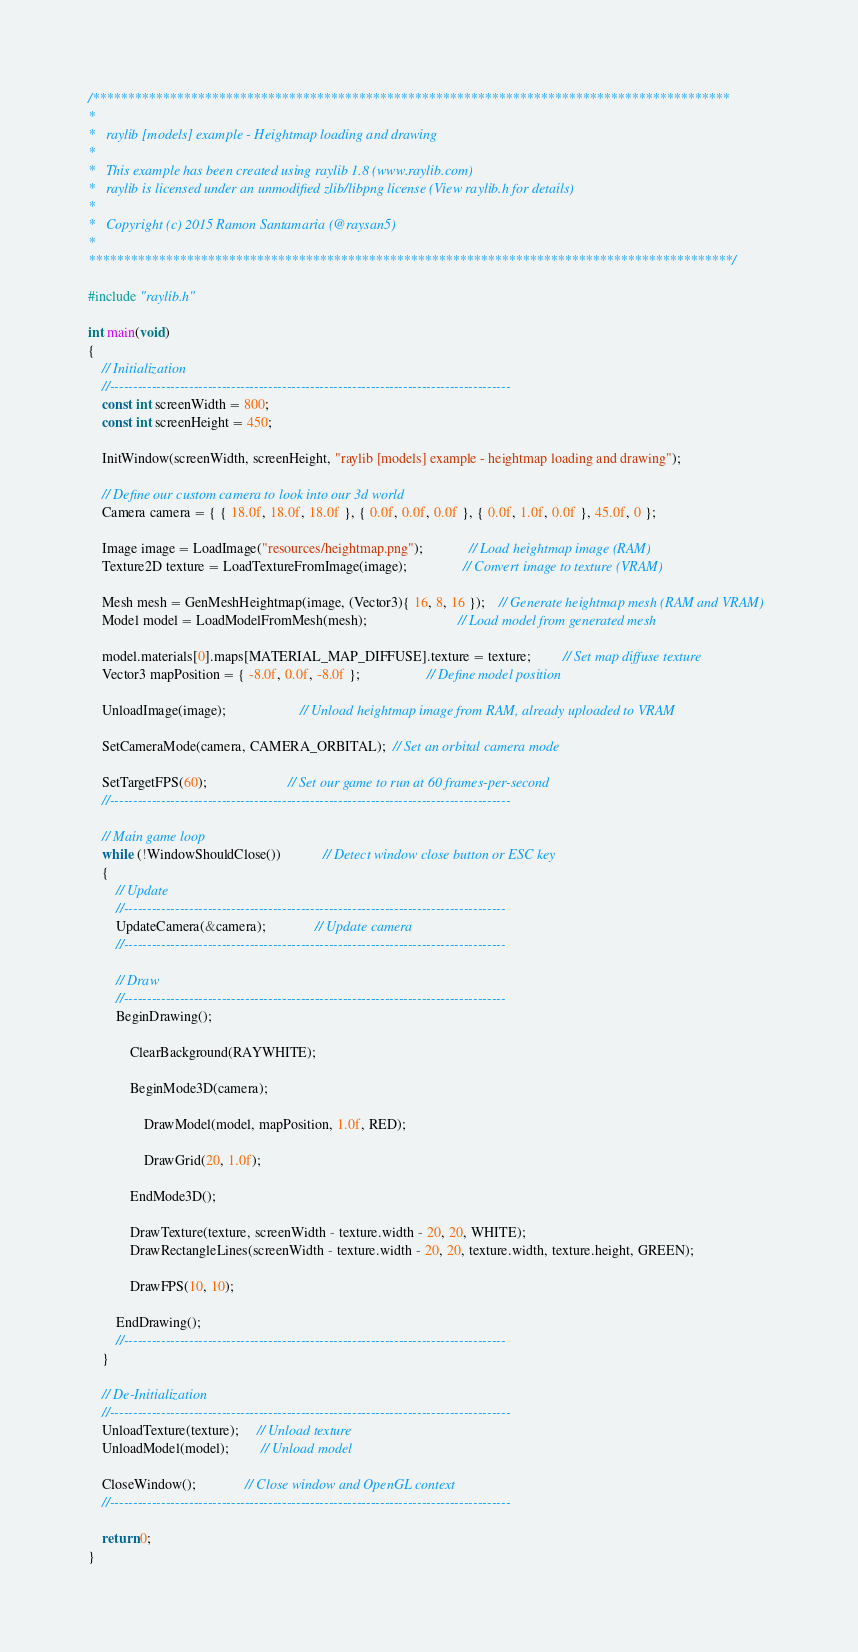Convert code to text. <code><loc_0><loc_0><loc_500><loc_500><_C_>/*******************************************************************************************
*
*   raylib [models] example - Heightmap loading and drawing
*
*   This example has been created using raylib 1.8 (www.raylib.com)
*   raylib is licensed under an unmodified zlib/libpng license (View raylib.h for details)
*
*   Copyright (c) 2015 Ramon Santamaria (@raysan5)
*
********************************************************************************************/

#include "raylib.h"

int main(void)
{
    // Initialization
    //--------------------------------------------------------------------------------------
    const int screenWidth = 800;
    const int screenHeight = 450;

    InitWindow(screenWidth, screenHeight, "raylib [models] example - heightmap loading and drawing");

    // Define our custom camera to look into our 3d world
    Camera camera = { { 18.0f, 18.0f, 18.0f }, { 0.0f, 0.0f, 0.0f }, { 0.0f, 1.0f, 0.0f }, 45.0f, 0 };

    Image image = LoadImage("resources/heightmap.png");             // Load heightmap image (RAM)
    Texture2D texture = LoadTextureFromImage(image);                // Convert image to texture (VRAM)

    Mesh mesh = GenMeshHeightmap(image, (Vector3){ 16, 8, 16 });    // Generate heightmap mesh (RAM and VRAM)
    Model model = LoadModelFromMesh(mesh);                          // Load model from generated mesh

    model.materials[0].maps[MATERIAL_MAP_DIFFUSE].texture = texture;         // Set map diffuse texture
    Vector3 mapPosition = { -8.0f, 0.0f, -8.0f };                   // Define model position

    UnloadImage(image);                     // Unload heightmap image from RAM, already uploaded to VRAM

    SetCameraMode(camera, CAMERA_ORBITAL);  // Set an orbital camera mode

    SetTargetFPS(60);                       // Set our game to run at 60 frames-per-second
    //--------------------------------------------------------------------------------------

    // Main game loop
    while (!WindowShouldClose())            // Detect window close button or ESC key
    {
        // Update
        //----------------------------------------------------------------------------------
        UpdateCamera(&camera);              // Update camera
        //----------------------------------------------------------------------------------

        // Draw
        //----------------------------------------------------------------------------------
        BeginDrawing();

            ClearBackground(RAYWHITE);

            BeginMode3D(camera);

                DrawModel(model, mapPosition, 1.0f, RED);

                DrawGrid(20, 1.0f);

            EndMode3D();

            DrawTexture(texture, screenWidth - texture.width - 20, 20, WHITE);
            DrawRectangleLines(screenWidth - texture.width - 20, 20, texture.width, texture.height, GREEN);

            DrawFPS(10, 10);

        EndDrawing();
        //----------------------------------------------------------------------------------
    }

    // De-Initialization
    //--------------------------------------------------------------------------------------
    UnloadTexture(texture);     // Unload texture
    UnloadModel(model);         // Unload model

    CloseWindow();              // Close window and OpenGL context
    //--------------------------------------------------------------------------------------

    return 0;
}</code> 